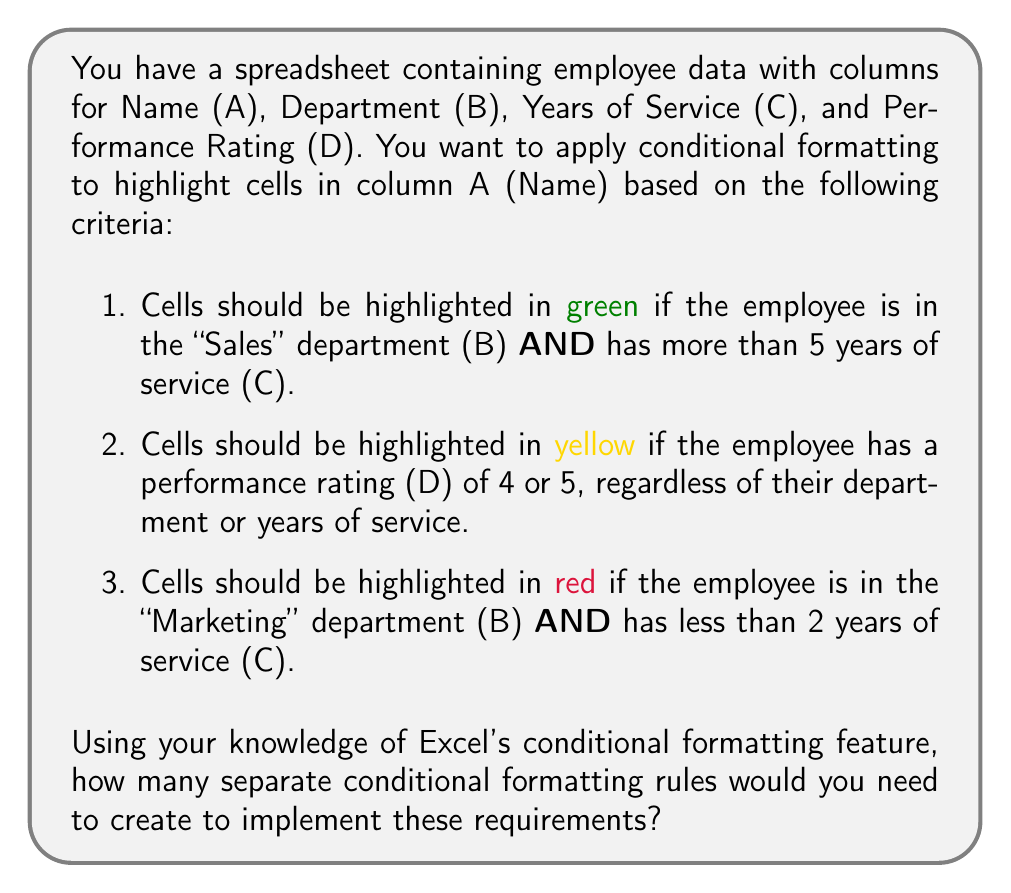Could you help me with this problem? To solve this problem, let's break down the requirements and analyze how they can be implemented using Excel's conditional formatting:

1. Green highlight:
   - Department = "Sales" AND Years of Service > 5
   This can be implemented as a single rule using a formula:
   $$\text{=AND(B2="Sales", C2>5)}$$

2. Yellow highlight:
   - Performance Rating ≥ 4
   This can be implemented as a single rule using a formula:
   $$\text{=OR(D2=4, D2=5)}$$

3. Red highlight:
   - Department = "Marketing" AND Years of Service < 2
   This can be implemented as a single rule using a formula:
   $$\text{=AND(B2="Marketing", C2<2)}$$

Each of these conditions requires a separate rule in Excel's conditional formatting feature. They cannot be combined into a single rule because they have different formatting outcomes (different colors) and use different logical combinations of criteria.

Therefore, to implement all these requirements, you would need to create three separate conditional formatting rules in Excel.

Step-by-step process:
1. Select column A (Name)
2. Go to Home > Conditional Formatting > New Rule
3. Create the first rule for the green highlight
4. Repeat steps 2-3 for the yellow highlight rule
5. Repeat steps 2-3 for the red highlight rule

Each rule would be applied to the same range (column A) but with different formulas and formatting options.
Answer: 3 rules 